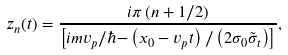<formula> <loc_0><loc_0><loc_500><loc_500>z _ { n } ( t ) = \frac { i \pi \left ( n + 1 / 2 \right ) } { \left [ i m v _ { p } / \hbar { - } \left ( x _ { 0 } - v _ { p } t \right ) / \left ( 2 \sigma _ { 0 } \tilde { \sigma } _ { t } \right ) \right ] } ,</formula> 